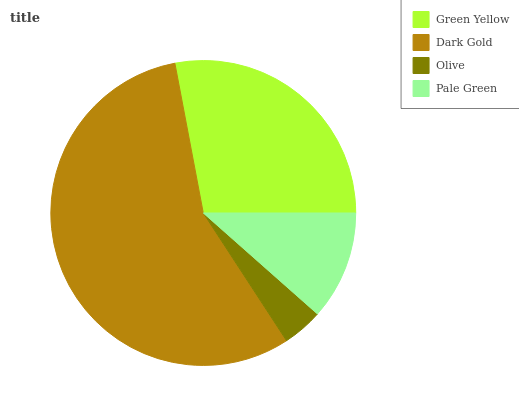Is Olive the minimum?
Answer yes or no. Yes. Is Dark Gold the maximum?
Answer yes or no. Yes. Is Dark Gold the minimum?
Answer yes or no. No. Is Olive the maximum?
Answer yes or no. No. Is Dark Gold greater than Olive?
Answer yes or no. Yes. Is Olive less than Dark Gold?
Answer yes or no. Yes. Is Olive greater than Dark Gold?
Answer yes or no. No. Is Dark Gold less than Olive?
Answer yes or no. No. Is Green Yellow the high median?
Answer yes or no. Yes. Is Pale Green the low median?
Answer yes or no. Yes. Is Pale Green the high median?
Answer yes or no. No. Is Olive the low median?
Answer yes or no. No. 